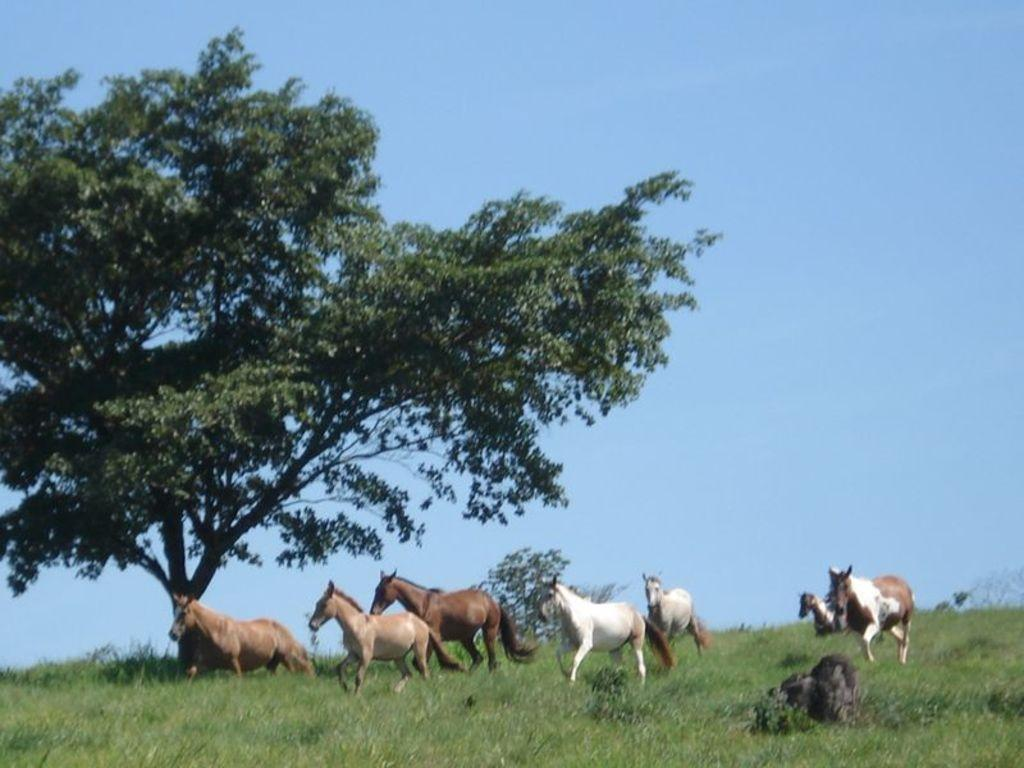What is happening in the foreground of the image? There are horses running in the foreground of the image. What is the surface the horses are running on? The horses are running on the grass. What can be seen in the background of the image, on the left side? There is a tree in the background of the image, on the left side. What is visible in the background of the image, at the top? The sky is visible in the background of the image, at the top. What type of balls are being used in the game with the net in the image? There is no game with a net present in the image; it features horses running on grass with a tree and sky in the background. 